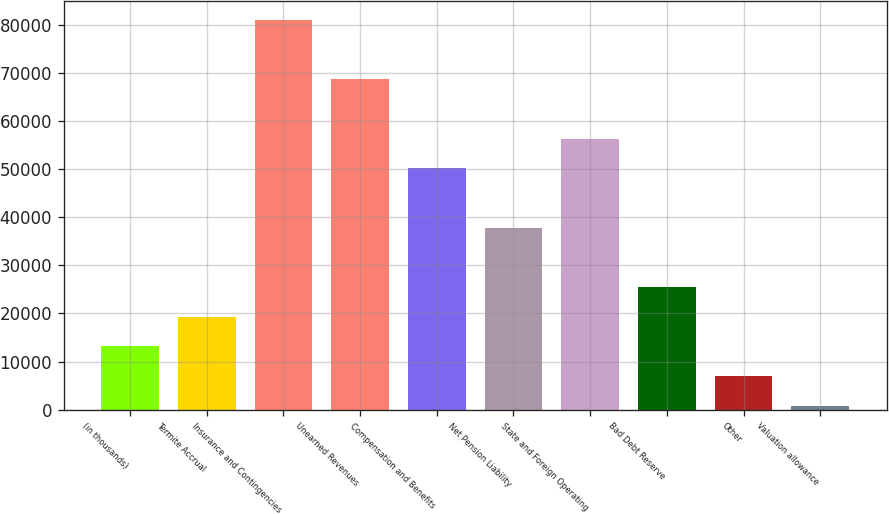<chart> <loc_0><loc_0><loc_500><loc_500><bar_chart><fcel>(in thousands)<fcel>Termite Accrual<fcel>Insurance and Contingencies<fcel>Unearned Revenues<fcel>Compensation and Benefits<fcel>Net Pension Liability<fcel>State and Foreign Operating<fcel>Bad Debt Reserve<fcel>Other<fcel>Valuation allowance<nl><fcel>13160.6<fcel>19335.9<fcel>81088.9<fcel>68738.3<fcel>50212.4<fcel>37861.8<fcel>56387.7<fcel>25511.2<fcel>6985.3<fcel>810<nl></chart> 